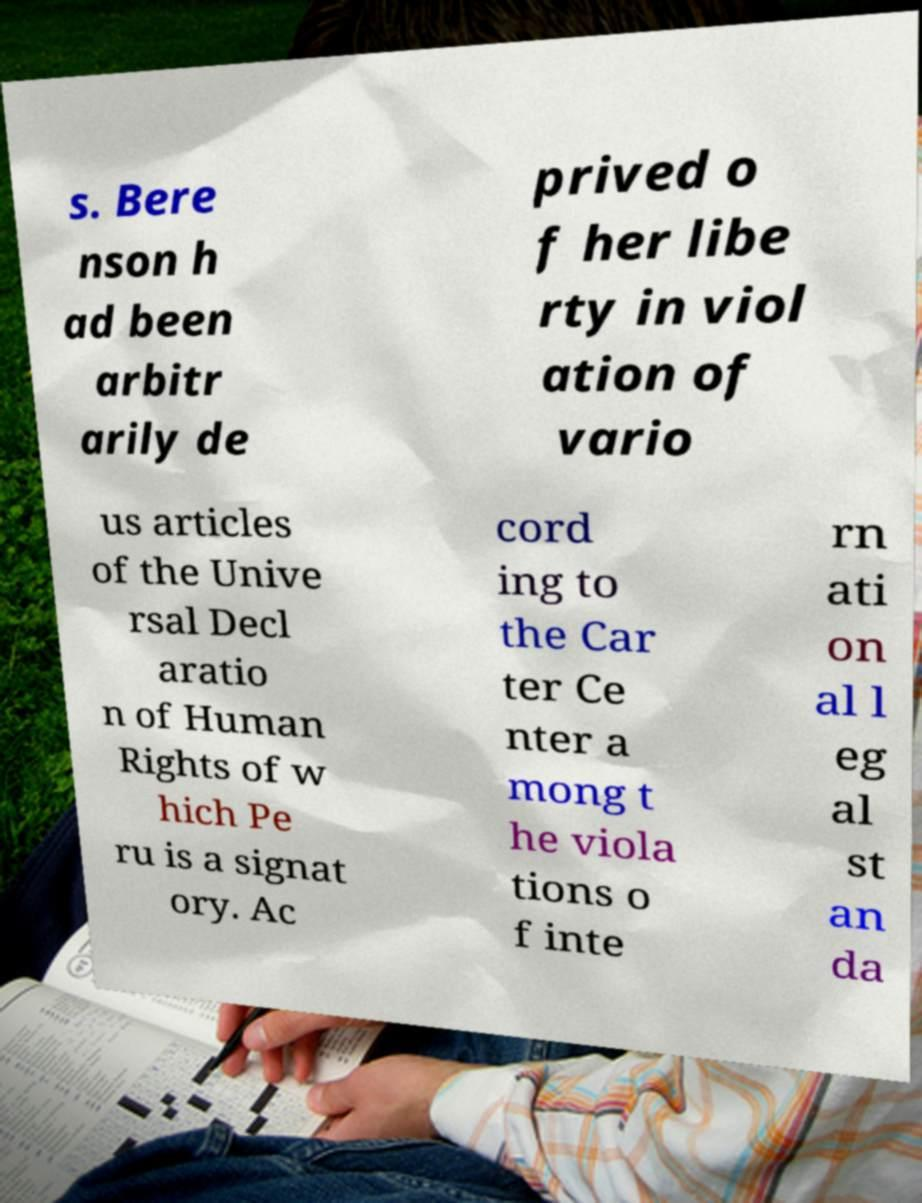Can you read and provide the text displayed in the image?This photo seems to have some interesting text. Can you extract and type it out for me? s. Bere nson h ad been arbitr arily de prived o f her libe rty in viol ation of vario us articles of the Unive rsal Decl aratio n of Human Rights of w hich Pe ru is a signat ory. Ac cord ing to the Car ter Ce nter a mong t he viola tions o f inte rn ati on al l eg al st an da 